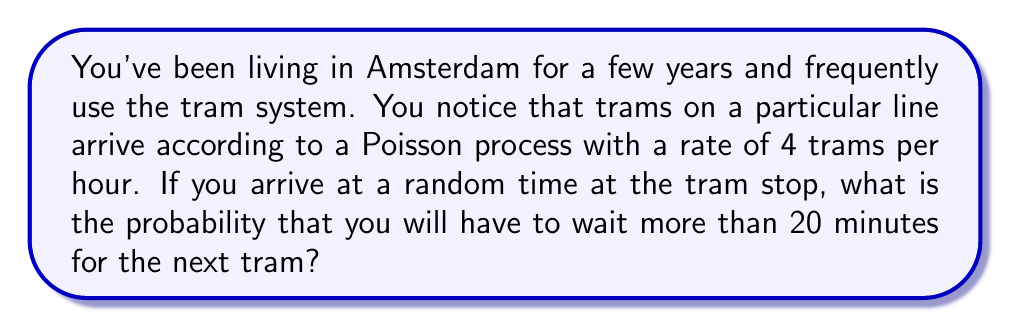Could you help me with this problem? Let's approach this step-by-step:

1) In a Poisson process, the time between events (in this case, tram arrivals) follows an exponential distribution.

2) The rate λ is given as 4 trams per hour. We need to convert this to trams per minute:
   $$ \lambda = \frac{4 \text{ trams}}{60 \text{ minutes}} = \frac{1}{15} \text{ trams per minute} $$

3) Let T be the waiting time for the next tram. We want to find P(T > 20).

4) For an exponential distribution with rate λ, the cumulative distribution function is:
   $$ F(t) = P(T \leq t) = 1 - e^{-\lambda t} $$

5) Therefore, the probability of waiting more than 20 minutes is:
   $$ P(T > 20) = 1 - P(T \leq 20) = 1 - (1 - e^{-\lambda 20}) = e^{-\lambda 20} $$

6) Substituting our λ value:
   $$ P(T > 20) = e^{-\frac{1}{15} \cdot 20} = e^{-\frac{4}{3}} $$

7) Calculating this value:
   $$ P(T > 20) \approx 0.2636 $$

Thus, the probability of waiting more than 20 minutes for the next tram is approximately 0.2636 or about 26.36%.
Answer: 0.2636 